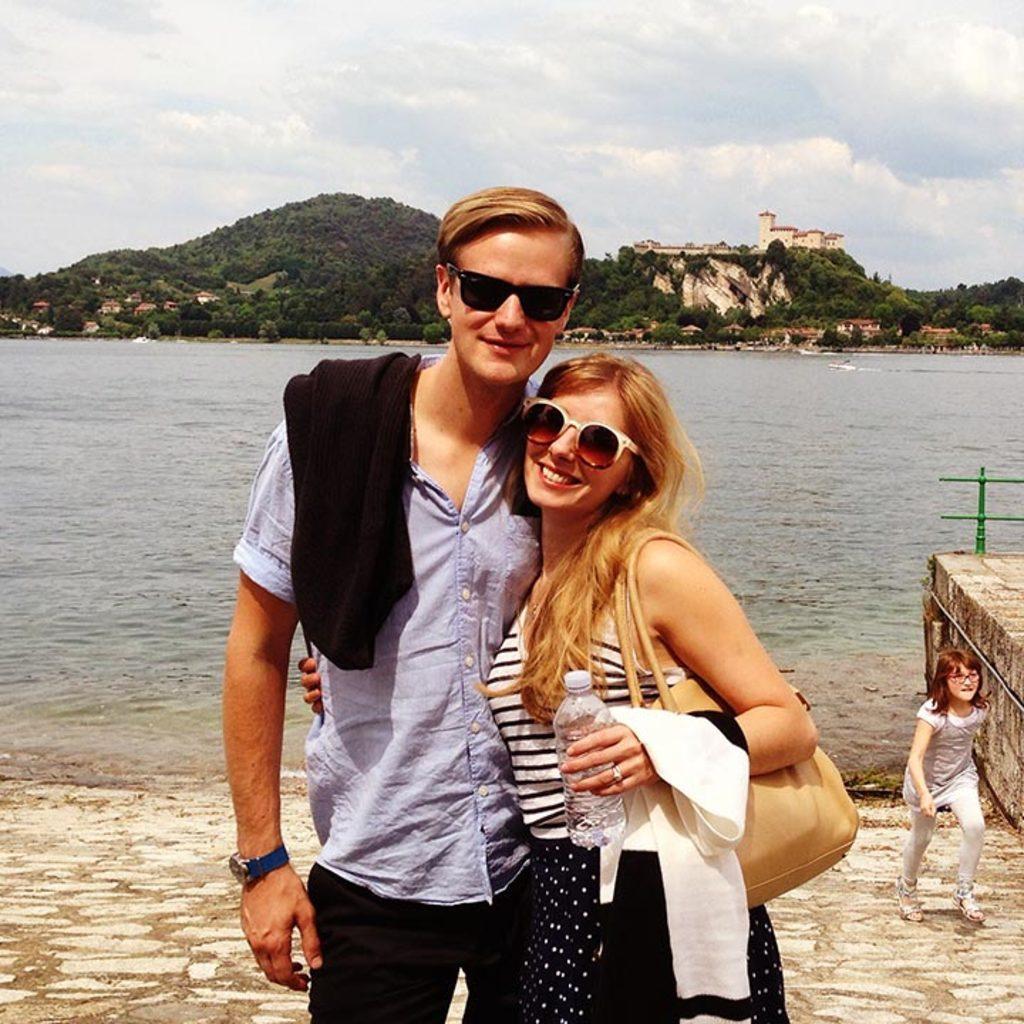In one or two sentences, can you explain what this image depicts? In the picture we can see a man and woman standing together and smiling and they are wearing shades and woman is wearing a hand bag and a bottle in her hand and in the background, we can see a girl standing and near to her we can see water and far from it we can see hills with trees and plants and some houses on it and behind it we can see a sky with clouds. 